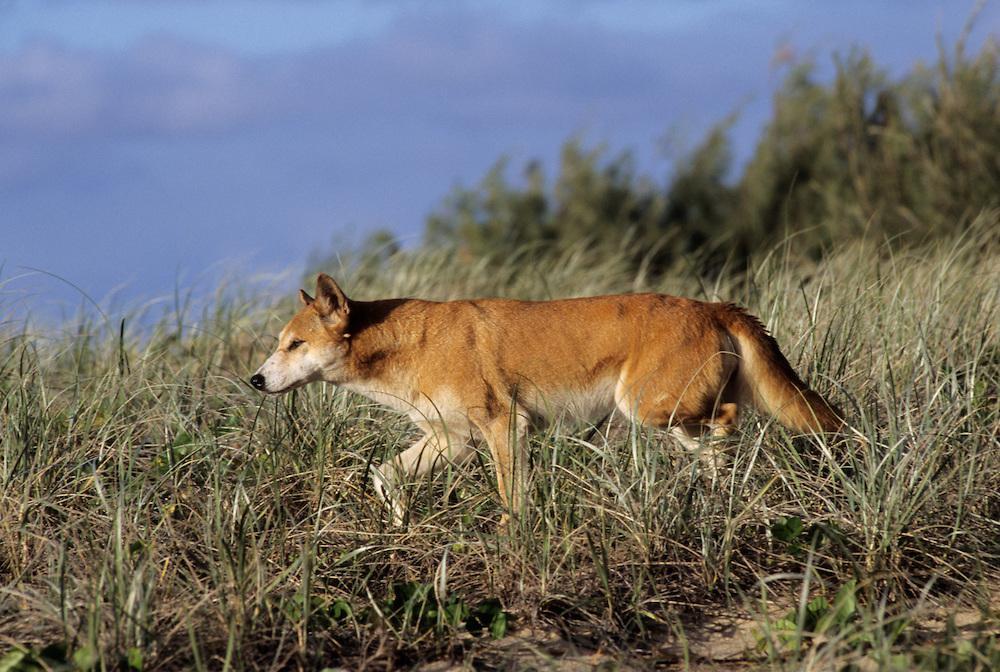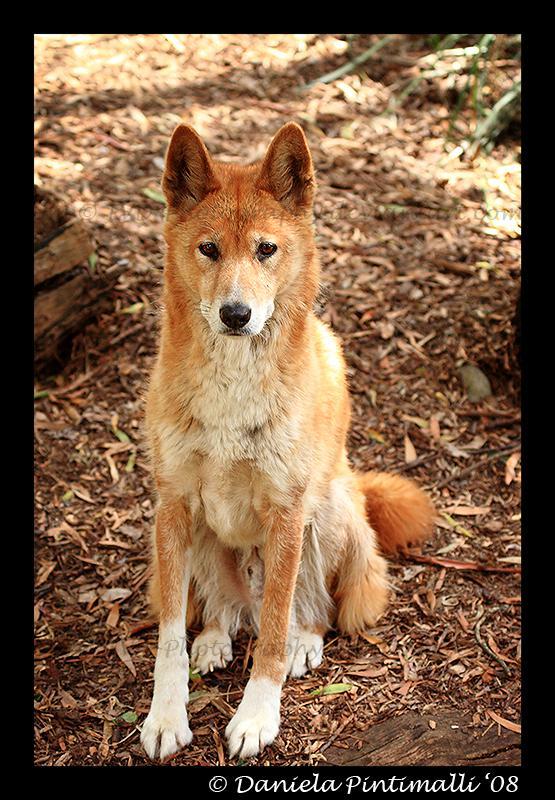The first image is the image on the left, the second image is the image on the right. Assess this claim about the two images: "An image shows one dog sitting upright on a rock, with its head and gaze angled leftward.". Correct or not? Answer yes or no. No. The first image is the image on the left, the second image is the image on the right. Assess this claim about the two images: "There are exactly two canines, outdoors.". Correct or not? Answer yes or no. Yes. 